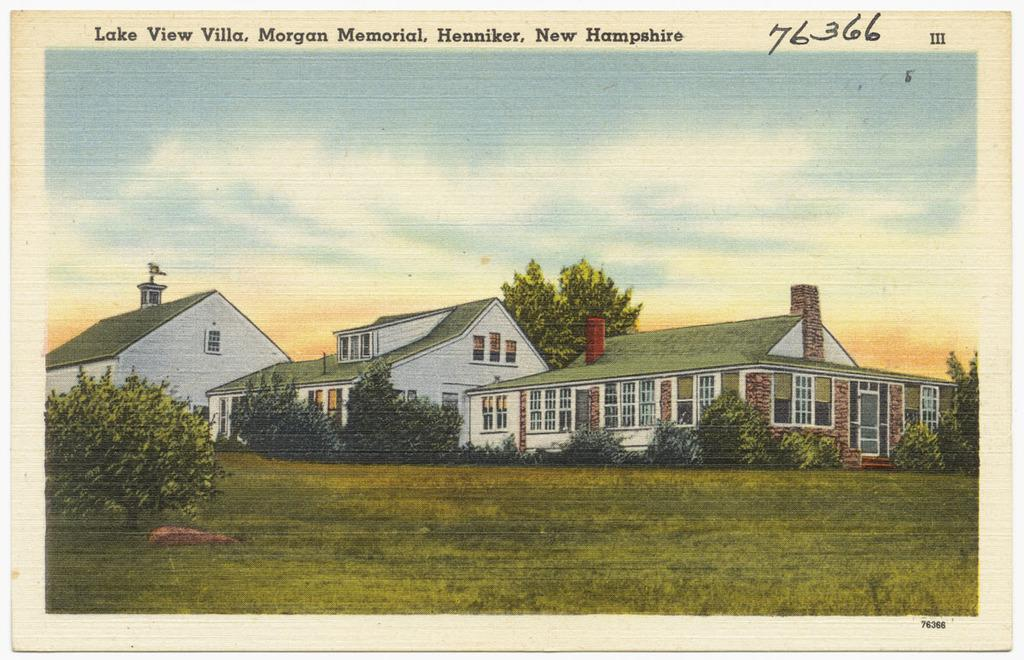<image>
Give a short and clear explanation of the subsequent image. A postcard from Lake View Villa, New Hampshire has a drawing of a house on the front of it. 